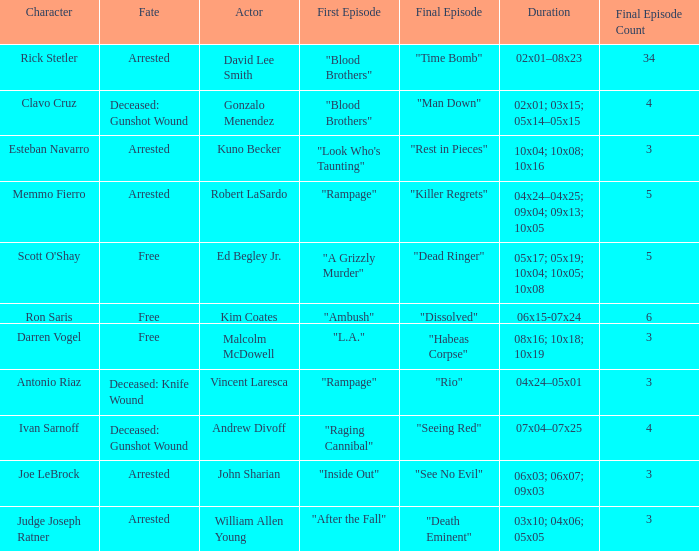What's the actor with character being judge joseph ratner William Allen Young. 